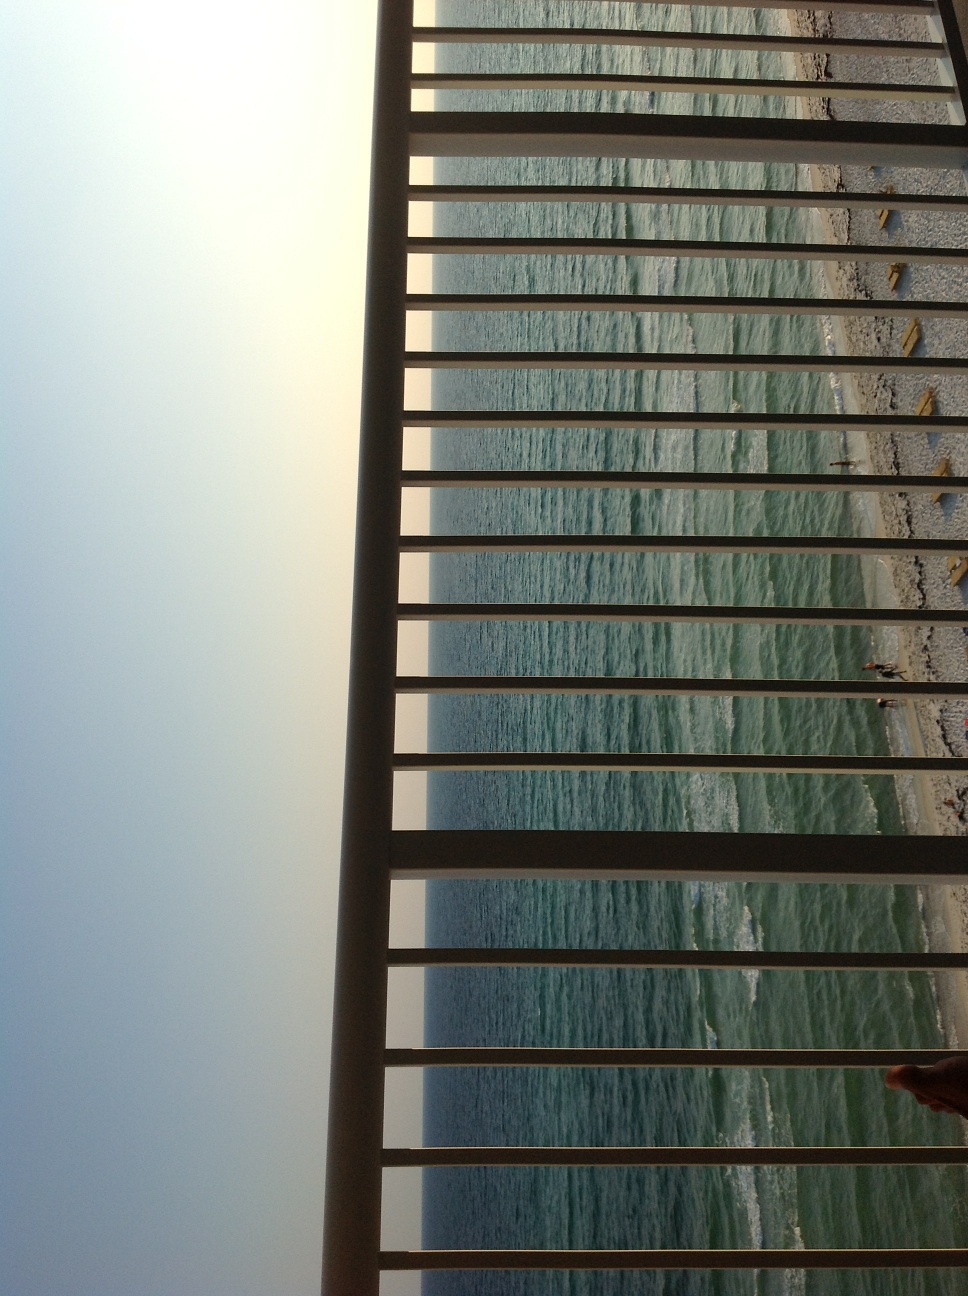What is this? This image captures a view of the ocean through the vertical bars of a railing, which might suggest a balcony or a similar structure. The perspective is intriguing as it includes the calming view of the waves juxtaposed with the strong, geometric lines of the bars, creating a frame that directs the viewer's focus towards the vastness of the sea. 